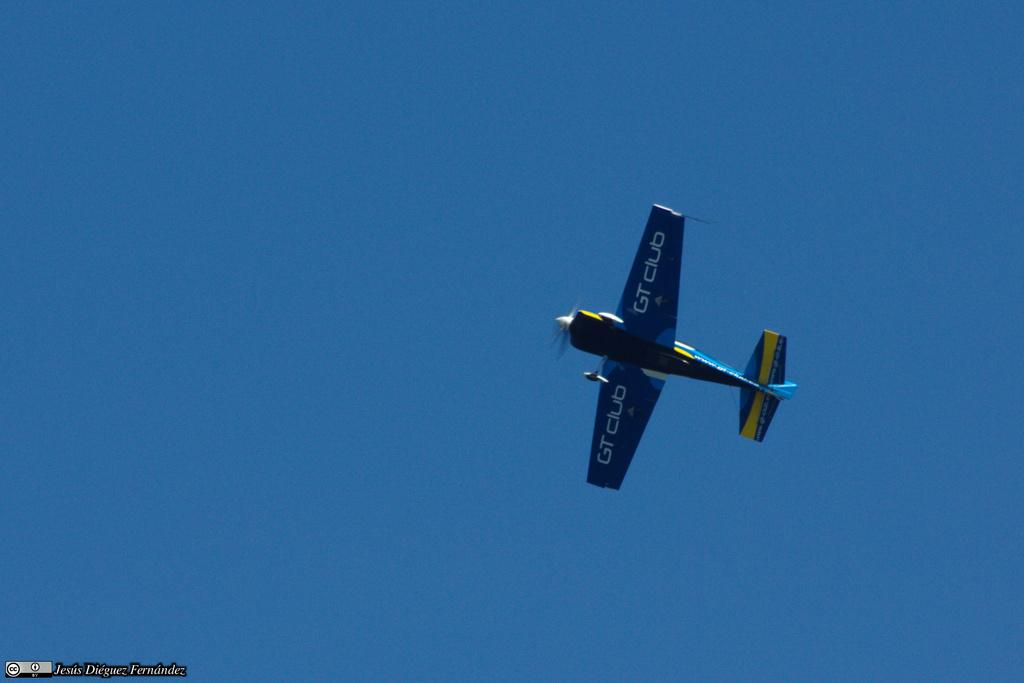What is the main subject of the image? The main subject of the image is an airplane. What is the airplane doing in the image? The airplane is flying in the sky. What time is it in the image? The provided facts do not mention a specific time, so it is not possible to determine the time from the image. 